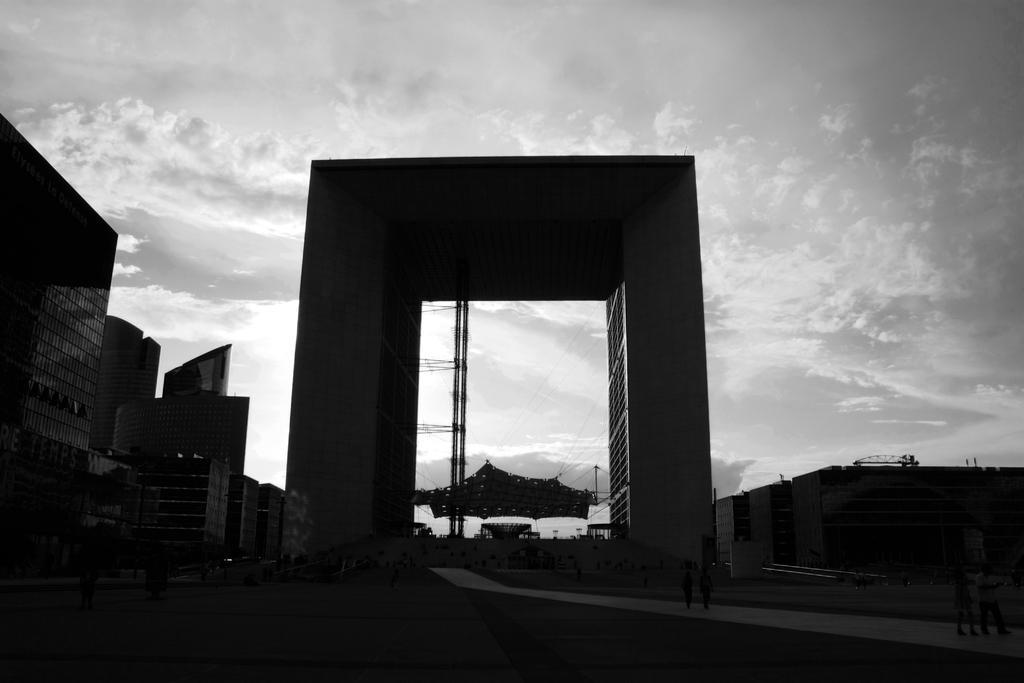Can you describe this image briefly? In this picture we can see a few buildings from left to right. Sky is cloudy. 